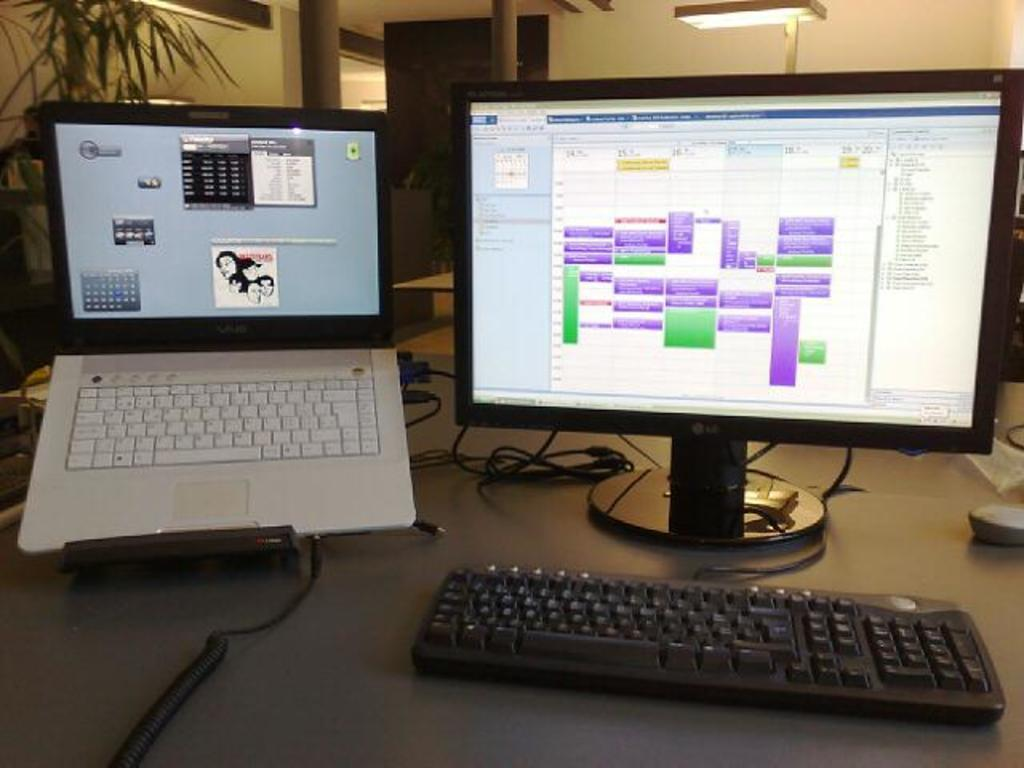What type of electronic devices are visible in the image? There is a laptop and a desktop in the image. What input device is present in the image? There is a keyboard with wires and a mouse in the image. What additional object can be seen in the image? There is a potted plant in the image. What structural elements are present in the image? There are poles in the image, and there is an entrance with a door. What lighting features are visible in the image? There are lights in the image. How many cakes are being served on the road in the image? There are no cakes or roads present in the image. What type of natural disaster is occurring in the image? There is no natural disaster, such as an earthquake, depicted in the image. 